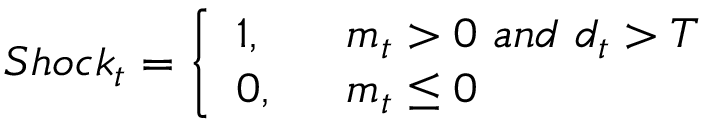Convert formula to latex. <formula><loc_0><loc_0><loc_500><loc_500>S h o c k _ { t } = \left \{ \begin{array} { l l } { 1 , } & { m _ { t } > 0 a n d d _ { t } > T } \\ { 0 , } & { m _ { t } \leq 0 } \end{array}</formula> 